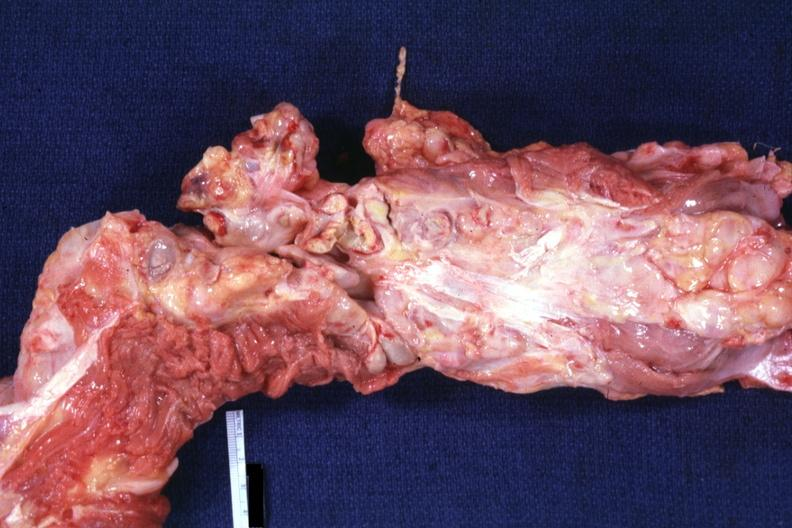what opened surrounded by large nodes?
Answer the question using a single word or phrase. Aorta not 